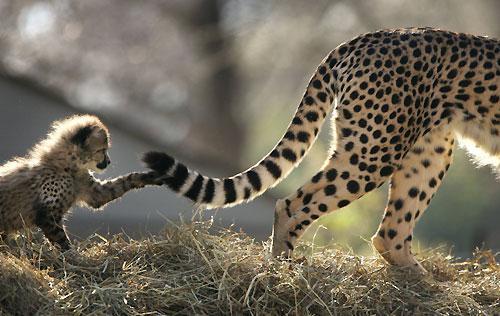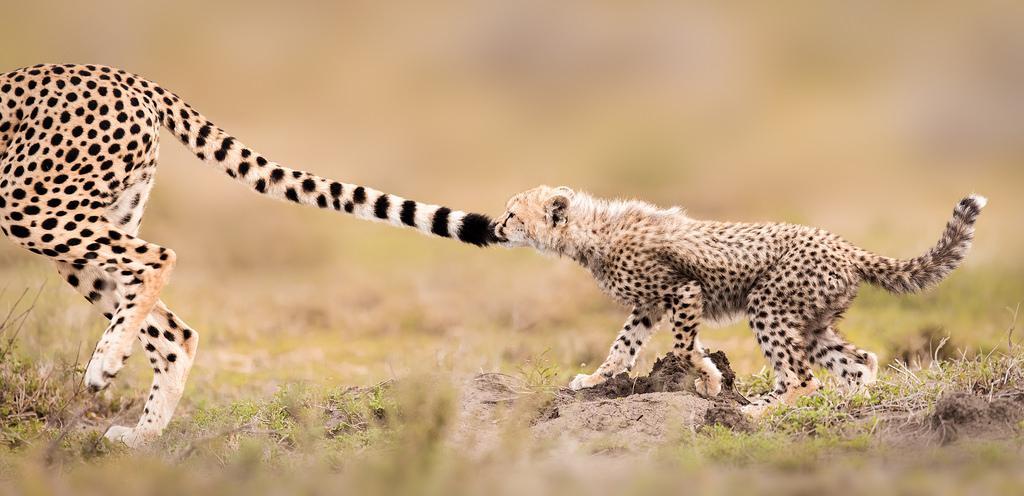The first image is the image on the left, the second image is the image on the right. Assess this claim about the two images: "There is one cheetah in the left image and two cheetahs in the right image". Correct or not? Answer yes or no. No. The first image is the image on the left, the second image is the image on the right. Assess this claim about the two images: "Cheeta cubs are playing with moms tail". Correct or not? Answer yes or no. Yes. 